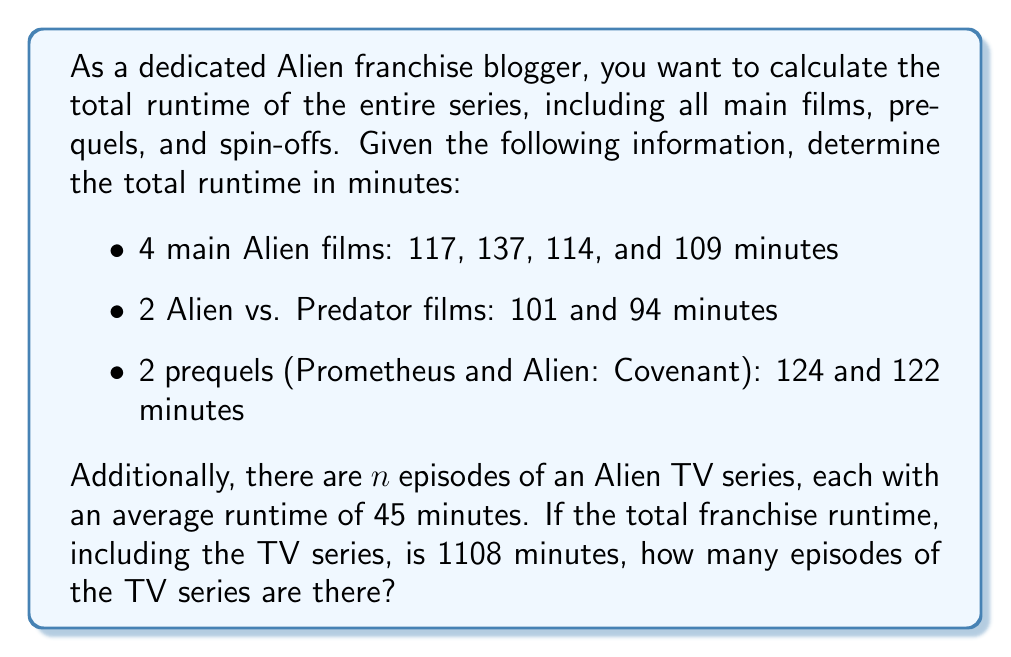Solve this math problem. Let's approach this problem step by step:

1. Calculate the total runtime of the main films:
   $$117 + 137 + 114 + 109 = 477 \text{ minutes}$$

2. Calculate the total runtime of the Alien vs. Predator films:
   $$101 + 94 = 195 \text{ minutes}$$

3. Calculate the total runtime of the prequels:
   $$124 + 122 = 246 \text{ minutes}$$

4. Sum up the total runtime of all films:
   $$477 + 195 + 246 = 918 \text{ minutes}$$

5. Set up an equation to solve for the number of TV episodes:
   Let $n$ be the number of episodes.
   $$918 + 45n = 1108$$

6. Solve for $n$:
   $$45n = 1108 - 918$$
   $$45n = 190$$
   $$n = \frac{190}{45} = \frac{38}{9} = 4\frac{2}{9}$$

Since we can't have a fractional number of episodes, we round down to the nearest whole number.
Answer: There are 4 episodes of the Alien TV series. 